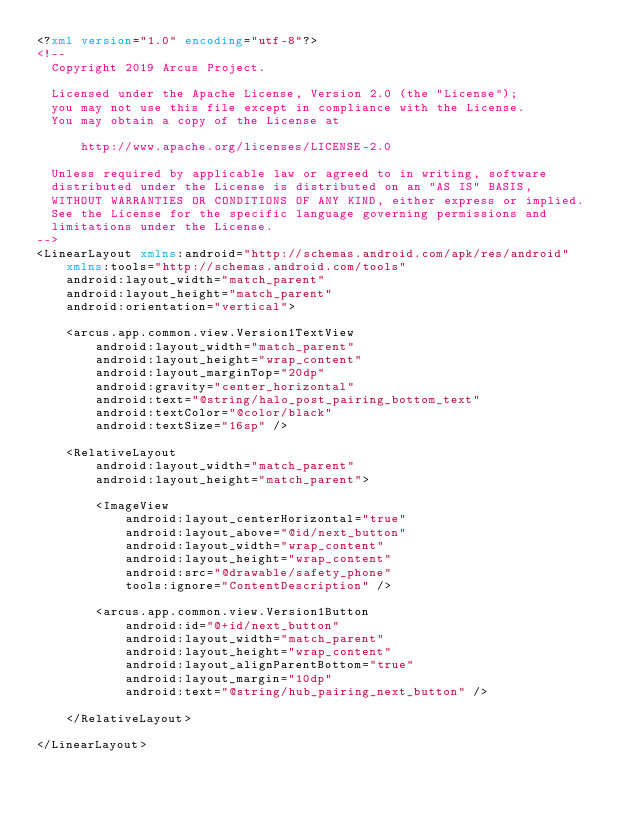<code> <loc_0><loc_0><loc_500><loc_500><_XML_><?xml version="1.0" encoding="utf-8"?>
<!--
  Copyright 2019 Arcus Project.

  Licensed under the Apache License, Version 2.0 (the "License");
  you may not use this file except in compliance with the License.
  You may obtain a copy of the License at

      http://www.apache.org/licenses/LICENSE-2.0

  Unless required by applicable law or agreed to in writing, software
  distributed under the License is distributed on an "AS IS" BASIS,
  WITHOUT WARRANTIES OR CONDITIONS OF ANY KIND, either express or implied.
  See the License for the specific language governing permissions and
  limitations under the License.
-->
<LinearLayout xmlns:android="http://schemas.android.com/apk/res/android"
    xmlns:tools="http://schemas.android.com/tools"
    android:layout_width="match_parent"
    android:layout_height="match_parent"
    android:orientation="vertical">

    <arcus.app.common.view.Version1TextView
        android:layout_width="match_parent"
        android:layout_height="wrap_content"
        android:layout_marginTop="20dp"
        android:gravity="center_horizontal"
        android:text="@string/halo_post_pairing_bottom_text"
        android:textColor="@color/black"
        android:textSize="16sp" />

    <RelativeLayout
        android:layout_width="match_parent"
        android:layout_height="match_parent">

        <ImageView
            android:layout_centerHorizontal="true"
            android:layout_above="@id/next_button"
            android:layout_width="wrap_content"
            android:layout_height="wrap_content"
            android:src="@drawable/safety_phone"
            tools:ignore="ContentDescription" />

        <arcus.app.common.view.Version1Button
            android:id="@+id/next_button"
            android:layout_width="match_parent"
            android:layout_height="wrap_content"
            android:layout_alignParentBottom="true"
            android:layout_margin="10dp"
            android:text="@string/hub_pairing_next_button" />

    </RelativeLayout>

</LinearLayout></code> 